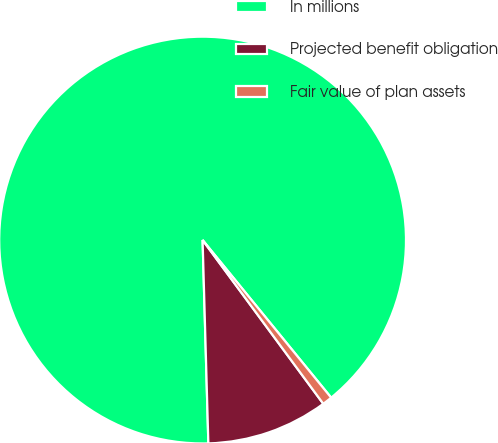Convert chart. <chart><loc_0><loc_0><loc_500><loc_500><pie_chart><fcel>In millions<fcel>Projected benefit obligation<fcel>Fair value of plan assets<nl><fcel>89.57%<fcel>9.66%<fcel>0.78%<nl></chart> 